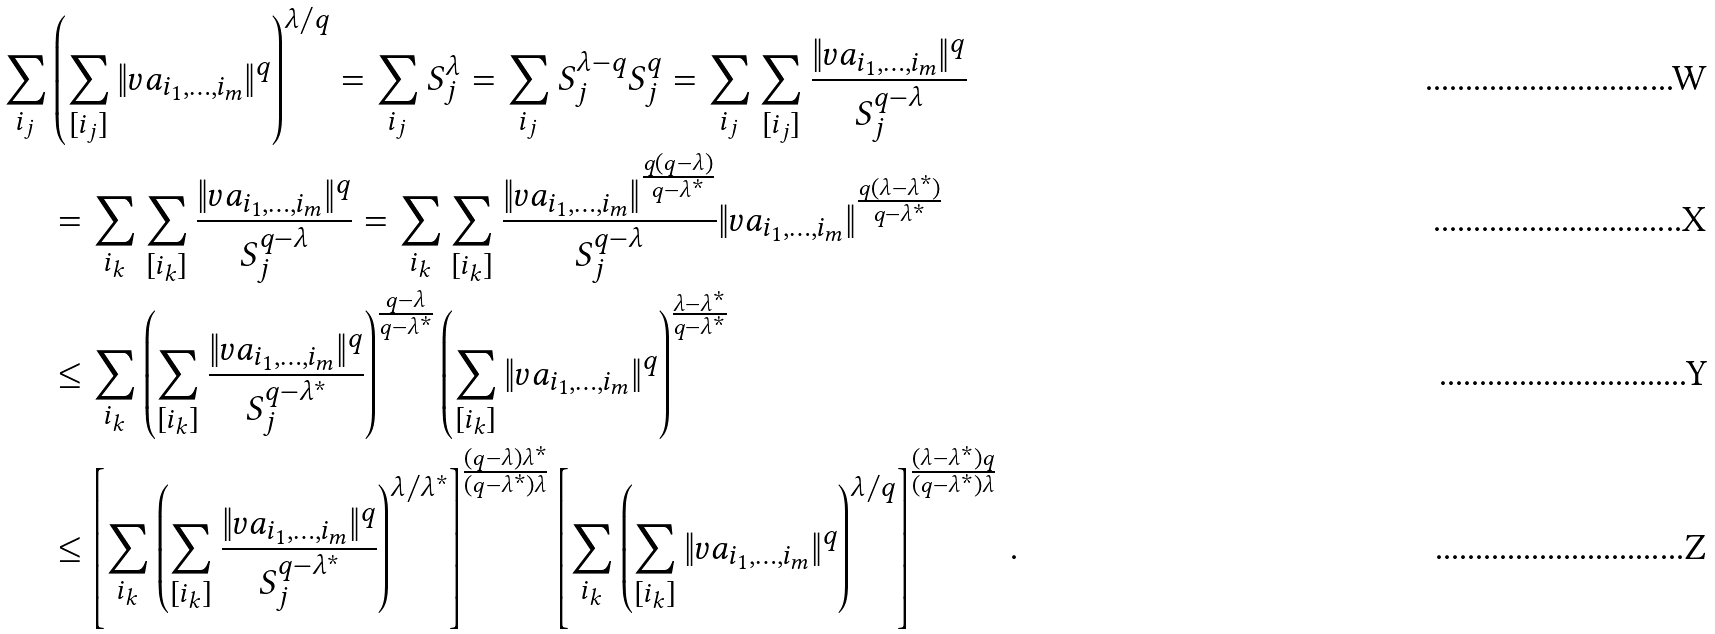<formula> <loc_0><loc_0><loc_500><loc_500>\sum _ { i _ { j } } & \left ( \sum _ { [ i _ { j } ] } \| v a _ { i _ { 1 } , \dots , i _ { m } } \| ^ { q } \right ) ^ { \lambda / q } = \sum _ { i _ { j } } S _ { j } ^ { \lambda } = \sum _ { i _ { j } } S _ { j } ^ { \lambda - q } S _ { j } ^ { q } = \sum _ { i _ { j } } \sum _ { [ i _ { j } ] } \frac { \| v a _ { i _ { 1 } , \dots , i _ { m } } \| ^ { q } } { S _ { j } ^ { q - \lambda } } \\ & = \sum _ { i _ { k } } \sum _ { [ i _ { k } ] } \frac { \| v a _ { i _ { 1 } , \dots , i _ { m } } \| ^ { q } } { S _ { j } ^ { q - \lambda } } = \sum _ { i _ { k } } \sum _ { [ i _ { k } ] } \frac { \| v a _ { i _ { 1 } , \dots , i _ { m } } \| ^ { \frac { q ( q - \lambda ) } { q - \lambda ^ { * } } } } { S _ { j } ^ { q - \lambda } } \| v a _ { i _ { 1 } , \dots , i _ { m } } \| ^ { \frac { q ( \lambda - \lambda ^ { * } ) } { q - \lambda ^ { * } } } \\ & \leq \sum _ { i _ { k } } \left ( \sum _ { [ i _ { k } ] } \frac { \| v a _ { i _ { 1 } , \dots , i _ { m } } \| ^ { q } } { S _ { j } ^ { q - \lambda ^ { * } } } \right ) ^ { \frac { q - \lambda } { q - \lambda ^ { * } } } \left ( \sum _ { [ i _ { k } ] } \| v a _ { i _ { 1 } , \dots , i _ { m } } \| ^ { q } \right ) ^ { \frac { \lambda - \lambda ^ { * } } { q - \lambda ^ { * } } } \\ & \leq \left [ \sum _ { i _ { k } } \left ( \sum _ { [ i _ { k } ] } \frac { \| v a _ { i _ { 1 } , \dots , i _ { m } } \| ^ { q } } { S _ { j } ^ { q - \lambda ^ { * } } } \right ) ^ { \lambda / \lambda ^ { * } } \right ] ^ { \frac { ( q - \lambda ) \lambda ^ { * } } { ( q - \lambda ^ { * } ) \lambda } } \left [ \sum _ { i _ { k } } \left ( \sum _ { [ i _ { k } ] } \| v a _ { i _ { 1 } , \dots , i _ { m } } \| ^ { q } \right ) ^ { \lambda / q } \right ] ^ { \frac { ( \lambda - \lambda ^ { * } ) q } { ( q - \lambda ^ { * } ) \lambda } } \, .</formula> 